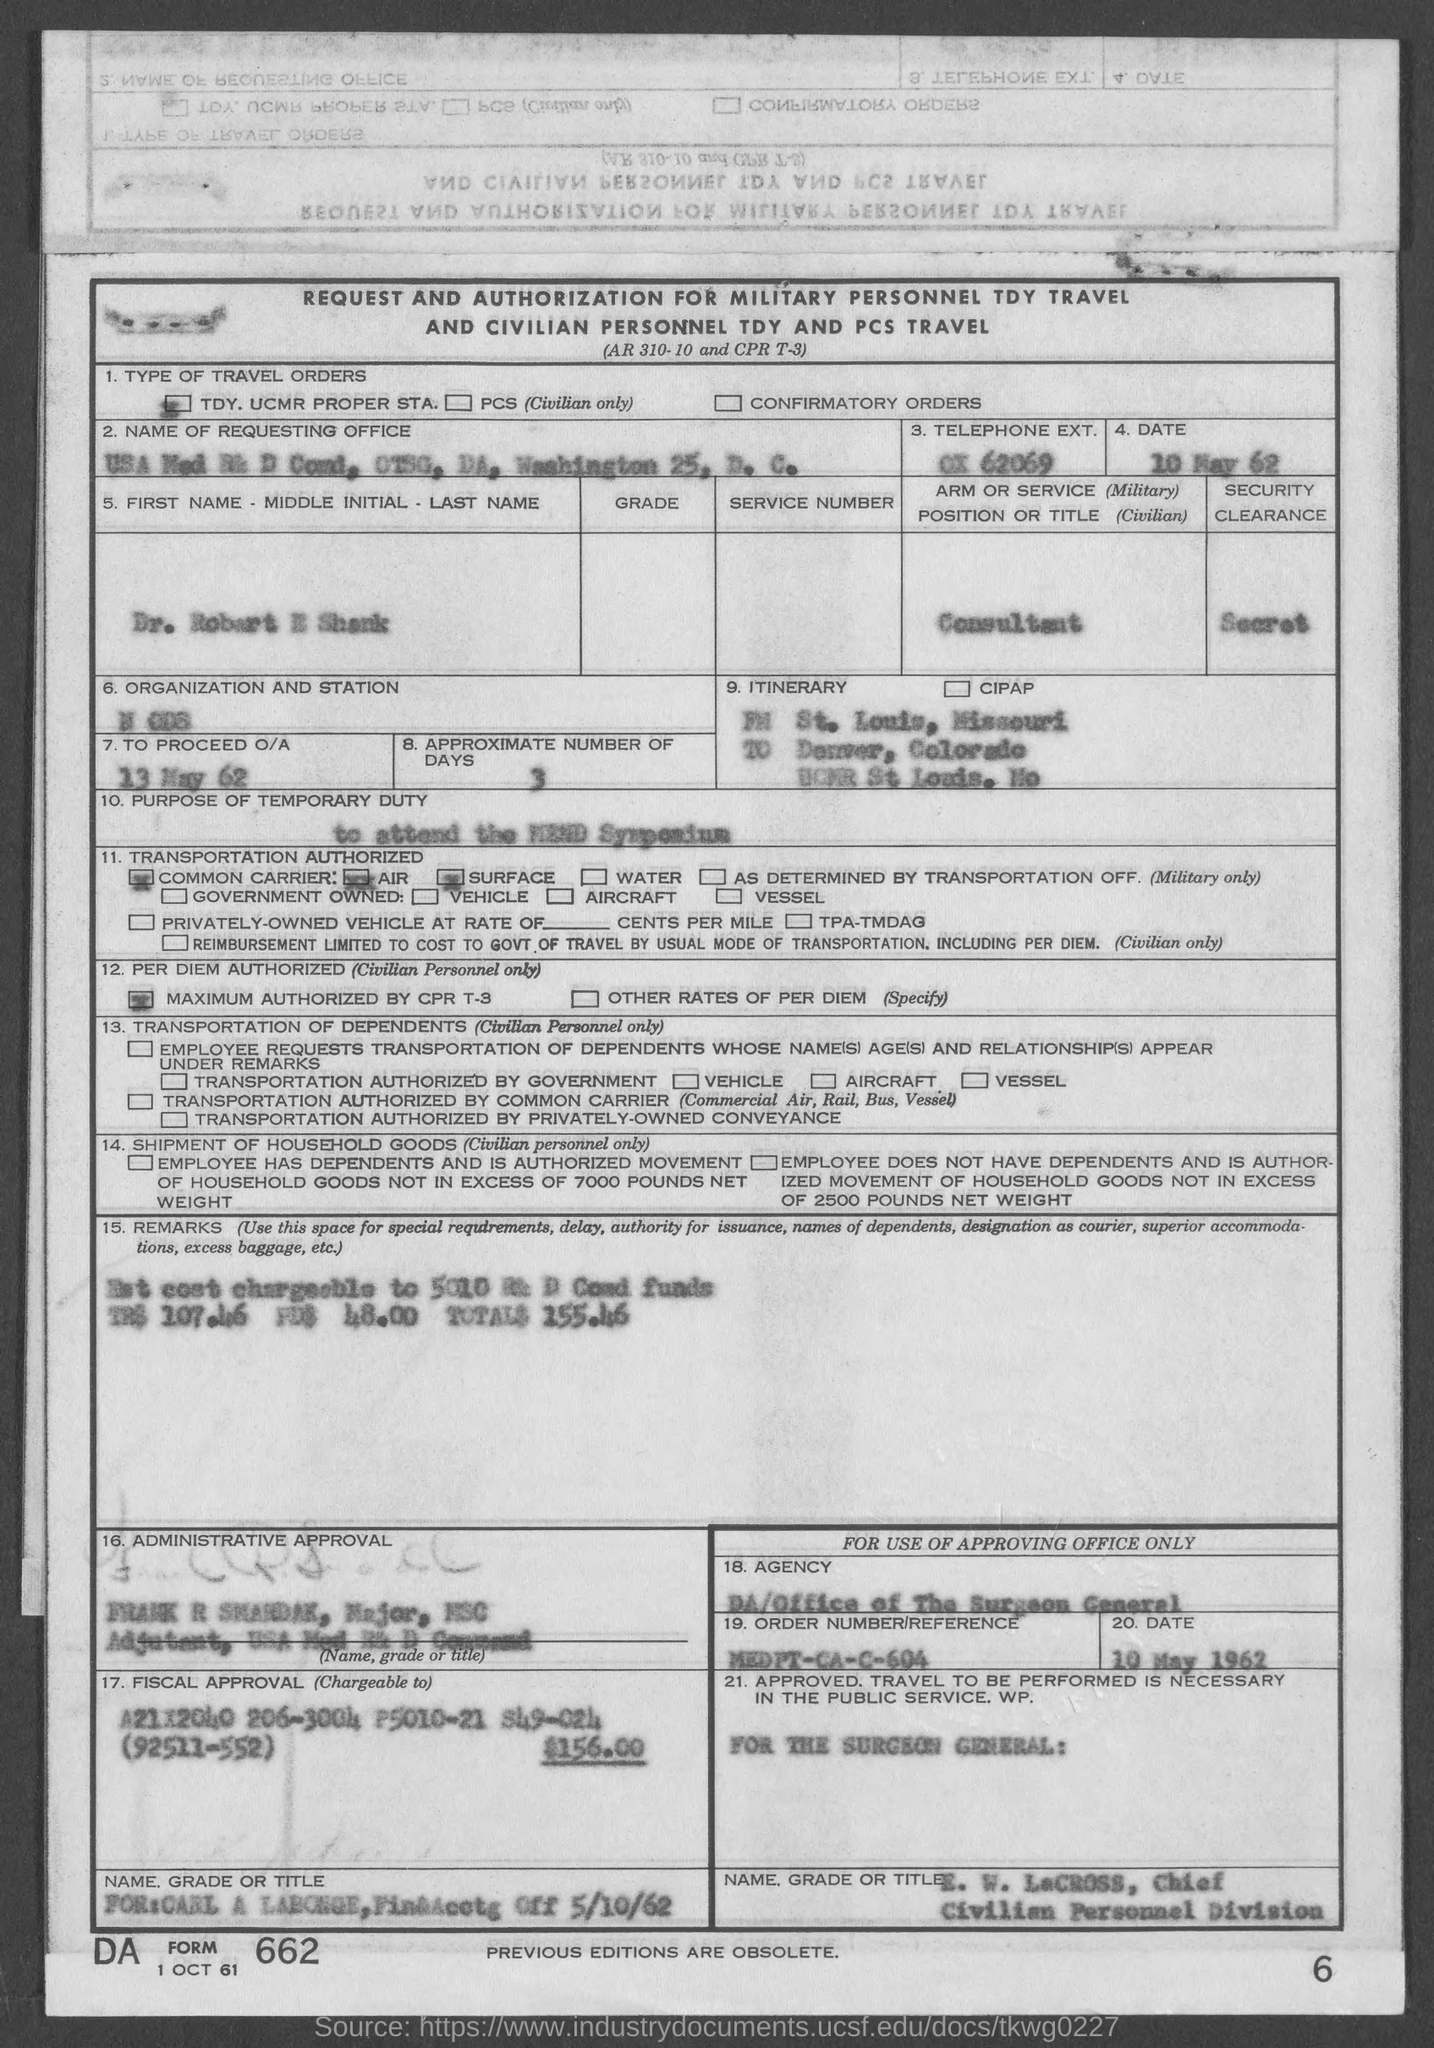What is the date mentioned in the given page ?
Your answer should be very brief. 10 MAY 62. What are the approximate number of days mentioned in the given page ?
Offer a very short reply. 3. What is the date to proceed o/a as mentioned in the given page ?
Keep it short and to the point. 13 MAY 62. What is the security clearance mentioned in the given page ?
Your answer should be compact. Secret. What is the position or title mentioned in the given form ?
Your response must be concise. Consultant. 